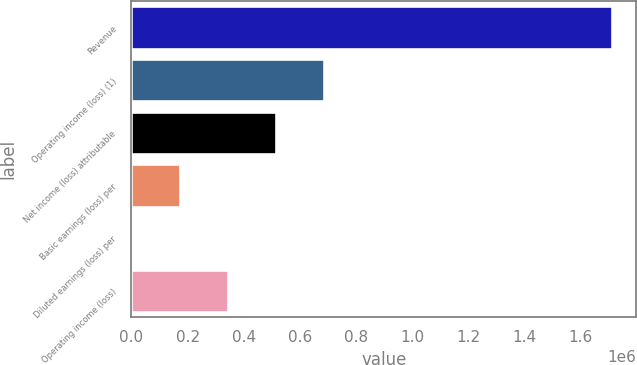<chart> <loc_0><loc_0><loc_500><loc_500><bar_chart><fcel>Revenue<fcel>Operating income (loss) (1)<fcel>Net income (loss) attributable<fcel>Basic earnings (loss) per<fcel>Diluted earnings (loss) per<fcel>Operating income (loss)<nl><fcel>1.7125e+06<fcel>685003<fcel>513753<fcel>171252<fcel>1.94<fcel>342502<nl></chart> 